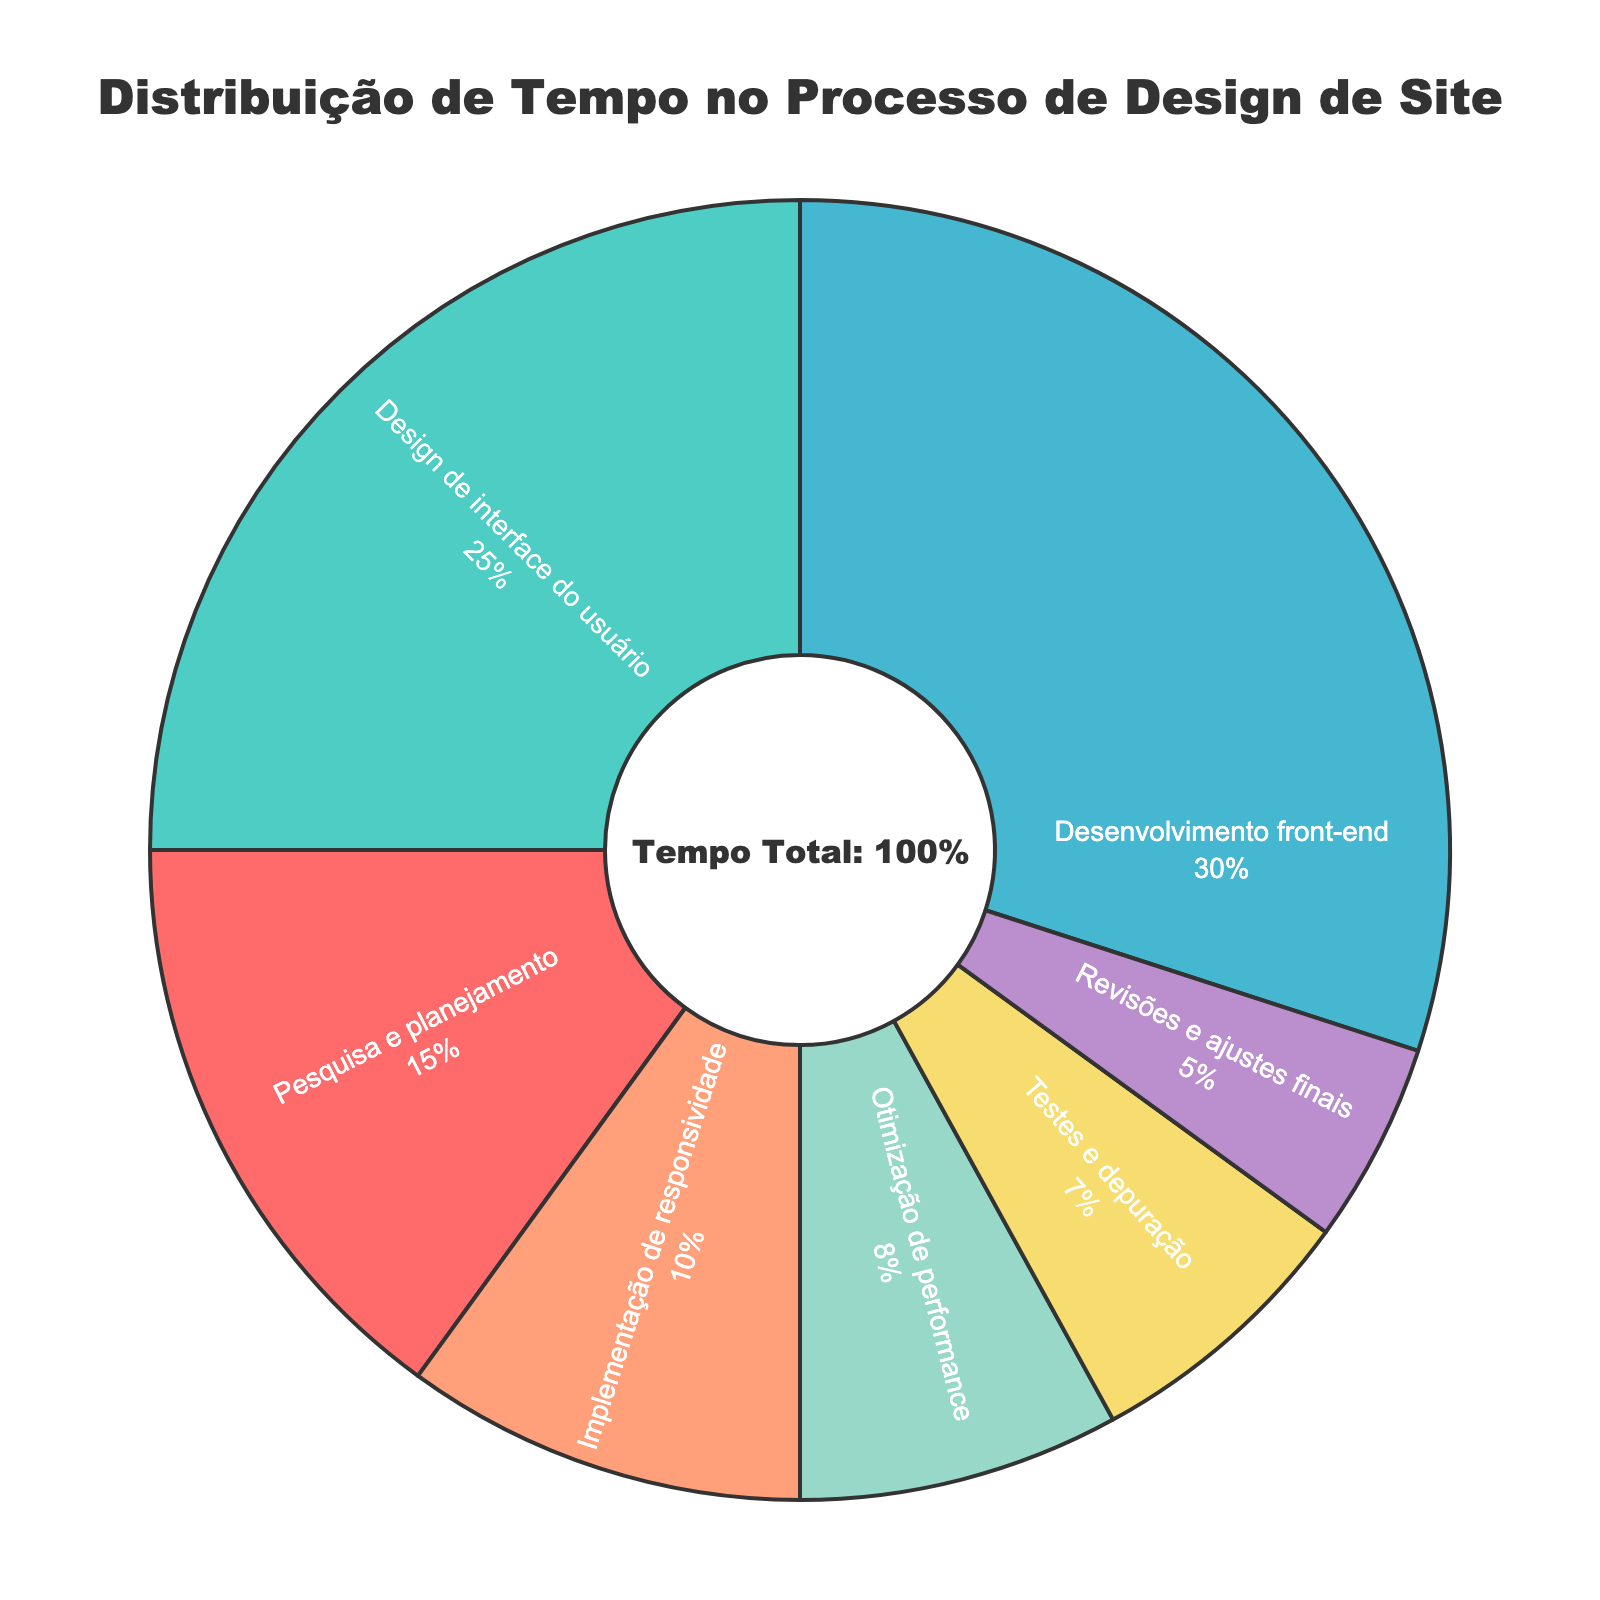Qual é a fase do processo de design que consome a maior porcentagem de tempo? A fase que mais consome tempo é aquela com a maior fatia no gráfico. No gráfico, a fase de Desenvolvimento front-end ocupa a maior porcentagem.
Answer: Desenvolvimento front-end Qual a diferença percentual entre o tempo gasto em Design de interface do usuário e Testes e depuração? Subtraindo a porcentagem de Testes e depuração (7%) da porcentagem de Design de interface do usuário (25%), chegamos à diferença percentual. 25% - 7% = 18%
Answer: 18% Quais fases juntas representam exatamente metade (50%) do tempo total? Somando as porcentagens das fases: Desenvolvimento front-end (30%) + Pesquisa e planejamento (15%) + Implementação de responsividade (10%) = 55%. Usando duas fases menores: Design de interface do usuário (25%) + Desenvolvimento front-end (30%) = 55%. Então não há combinação exata que forme 50%, mas a soma mais próxima é: Desenvolvimento front-end (30%) + Implementação de responsividade (10%) + Otimização de performance (8%) + Testes e depuração (7%) = 55%.
Answer: Nenhuma, a soma mais próxima é 55% Qual fase tem a menor porcentagem de tempo dedicado? A fase com a menor fatia no gráfico de pizza é a fase de Revisões e ajustes finais com 5%.
Answer: Revisões e ajustes finais O tempo gasto com Design de interface do usuário é maior, menor ou igual ao tempo gasto com Pesquisa e planejamento e Otimização de performance juntos? Somando as porcentagens de Pesquisa e planejamento (15%) e Otimização de performance (8%), obtemos 23%. A porcentagem de Design de interface do usuário é 25%, que é maior que 23%.
Answer: Maior Qual é a diferença entre a soma das porcentagens das fases que usam menos de 10% do tempo cada e a fase que mais ocupa tempo? Somando as porcentagens das fases que usam menos de 10%: Implementação de responsividade (10%) + Otimização de performance (8%) + Testes e depuração (7%) + Revisões e ajustes finais (5%) = 30%. A fase que mais ocupa tempo, Desenvolvimento front-end, é 30%. A diferença é 30% - 30% = 0%.
Answer: 0% Quais são as fases cuja soma das porcentagens se iguala a 45%? Verificando por combinações de fases, Observamos que: Desenvolvimento front-end (30%) + Design de interface do usuário (25%) = 55%, portanto: Design de interface do usuário (25%) + Pesquisa e planejamento (15%) + Revisões e ajustes finais (5%) = 30% + 15% = 45%.
Answer: Não tem exata Se juntarmos as fases com porcentagens menos que 15%, que porcentagem resultaria? Somando as porcentagens das fases abaixo de 15% temos: Implementação de responsividade (10%) + Otimização de performance (8%) + Testes e depuração (7%) + Revisões e ajustes finais (5%) = 30%.
Answer: 30% Qual fase tem uma fatia na cor rosa no gráfico? A cor rosa no gráfico representa uma fase específica. Observando as cores, a fase Pesquisa e planejamento está representada na cor rosa.
Answer: Pesquisa e planejamento 